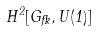<formula> <loc_0><loc_0><loc_500><loc_500>H ^ { 2 } [ G _ { \Psi } , U ( 1 ) ]</formula> 